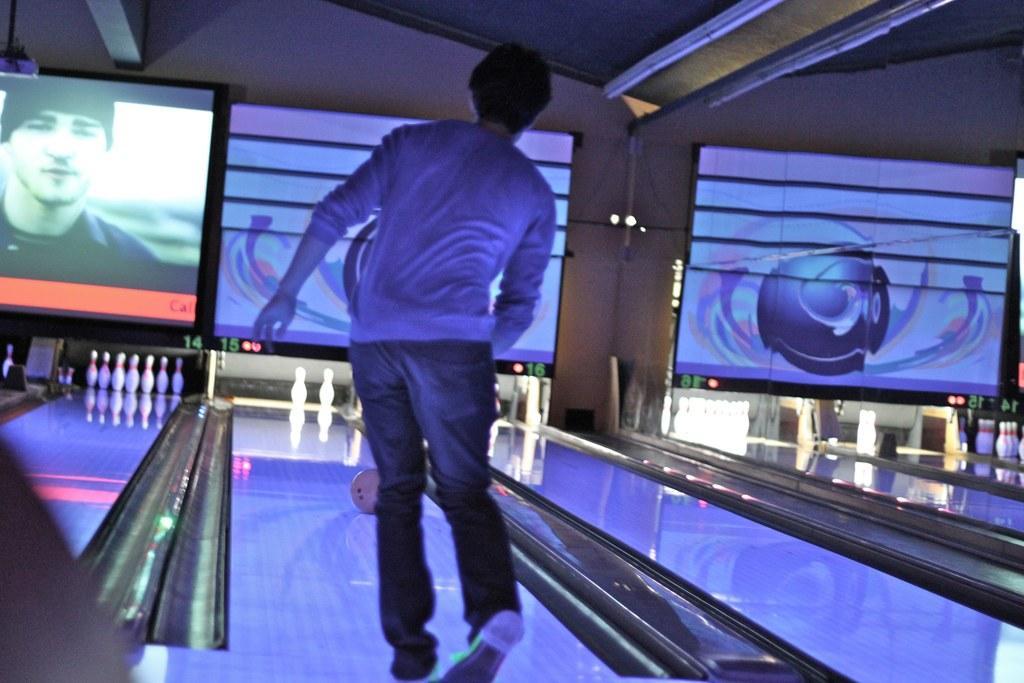Describe this image in one or two sentences. In this picture I can see a person standing, there is a bowling ball, there are bowling pins, there are screens, and in the background there is a wall. 